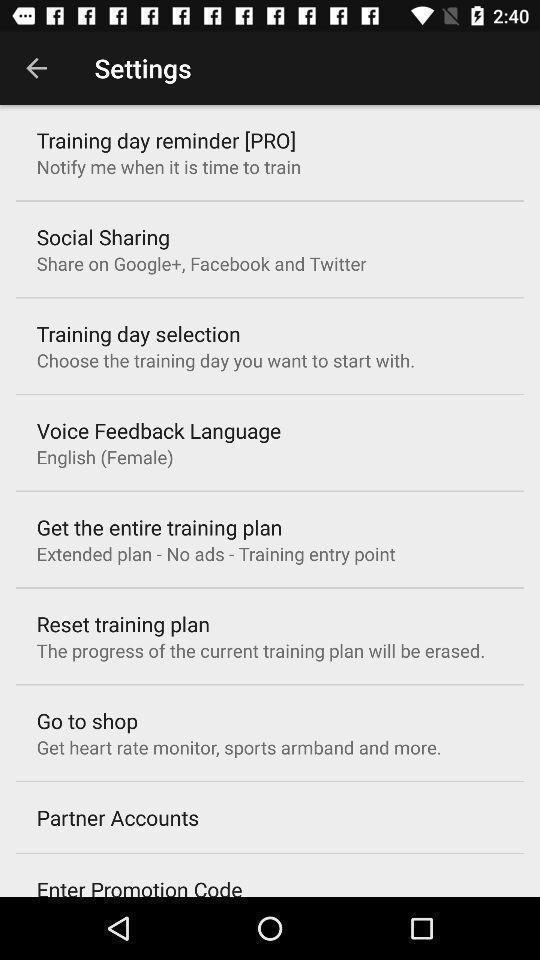Please provide a description for this image. Settings page. 